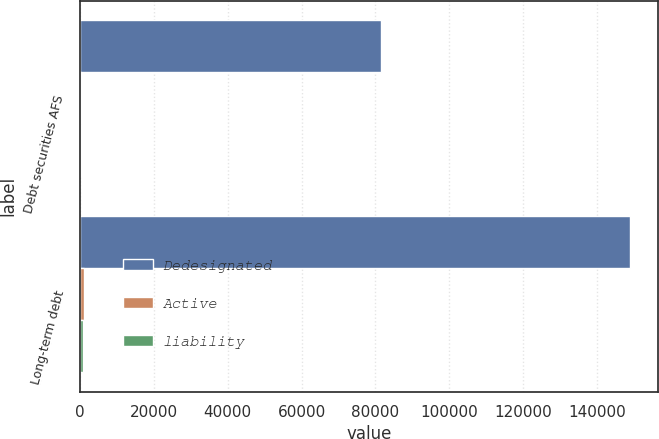Convert chart. <chart><loc_0><loc_0><loc_500><loc_500><stacked_bar_chart><ecel><fcel>Debt securities AFS<fcel>Long-term debt<nl><fcel>Dedesignated<fcel>81632<fcel>149054<nl><fcel>Active<fcel>196<fcel>1211<nl><fcel>liability<fcel>295<fcel>869<nl></chart> 